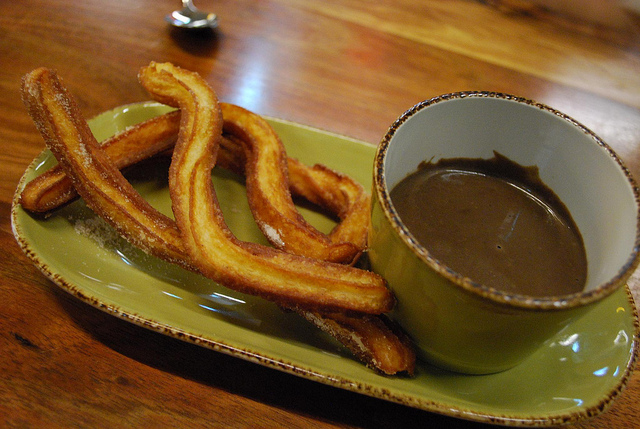What could be the story behind these churros? These churros were made following a century-old family recipe passed down through generations in a small Spanish village. The recipe was a closely guarded secret, known only to the women of the family, who would gather every weekend to prepare these treats for their loved ones. Today, this tradition is kept alive by Maria, who makes these churros with the sharegpt4v/same love and care, sharing a piece of her heritage with everyone who tastes them. How would this plate of churros change in a winter holiday setting? In a winter holiday setting, these churros would be dusted with cinnamon and nutmeg, filling the air with warm, festive spices. The chocolate would be enhanced with a hint of peppermint, adding a refreshing twist to each dip. The scene would be completed with holiday decorations, twinkling lights, and perhaps a sprinkle of powdered sugar to mimic freshly fallen snow. 